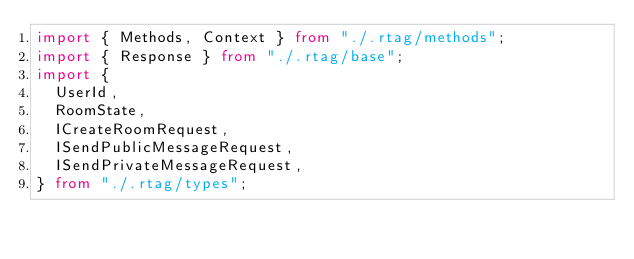Convert code to text. <code><loc_0><loc_0><loc_500><loc_500><_TypeScript_>import { Methods, Context } from "./.rtag/methods";
import { Response } from "./.rtag/base";
import {
  UserId,
  RoomState,
  ICreateRoomRequest,
  ISendPublicMessageRequest,
  ISendPrivateMessageRequest,
} from "./.rtag/types";
</code> 